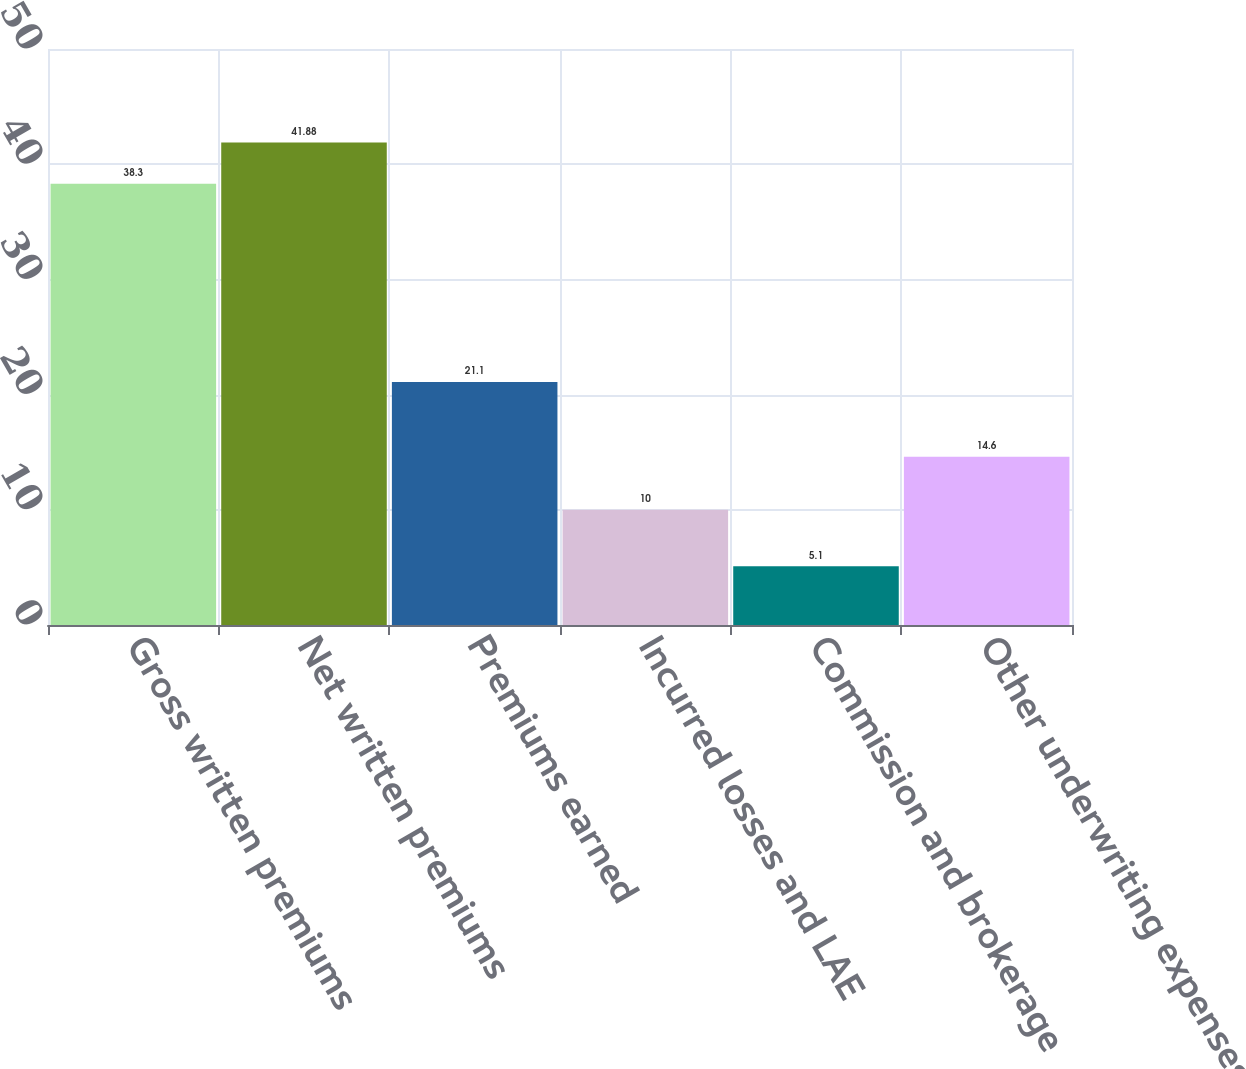Convert chart. <chart><loc_0><loc_0><loc_500><loc_500><bar_chart><fcel>Gross written premiums<fcel>Net written premiums<fcel>Premiums earned<fcel>Incurred losses and LAE<fcel>Commission and brokerage<fcel>Other underwriting expenses<nl><fcel>38.3<fcel>41.88<fcel>21.1<fcel>10<fcel>5.1<fcel>14.6<nl></chart> 